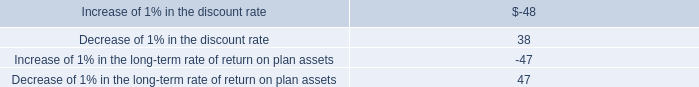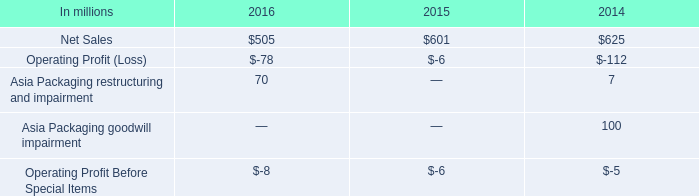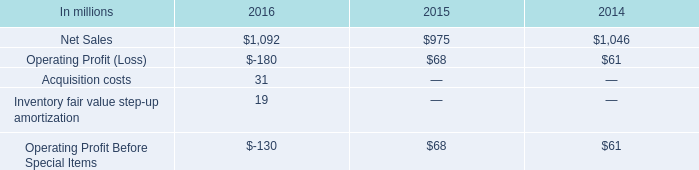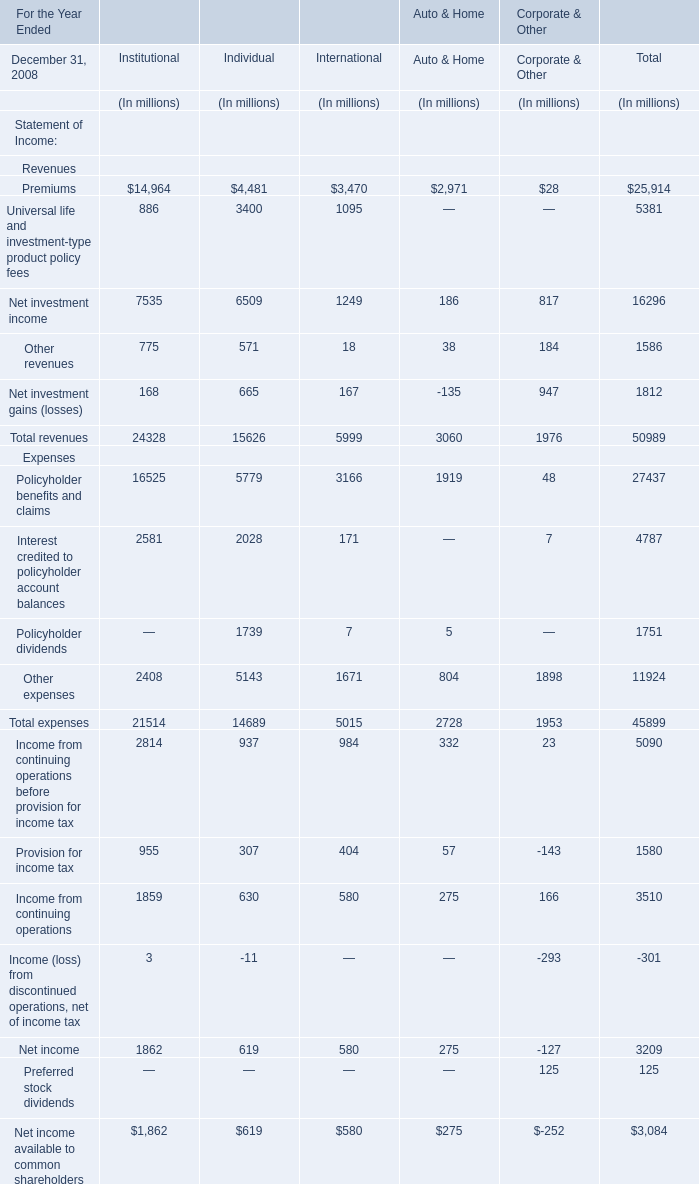what was the net reduction in defined benefit obligations between december 31 , 2012 and 2011 , in millions? 
Computations: (764 - 679)
Answer: 85.0. 